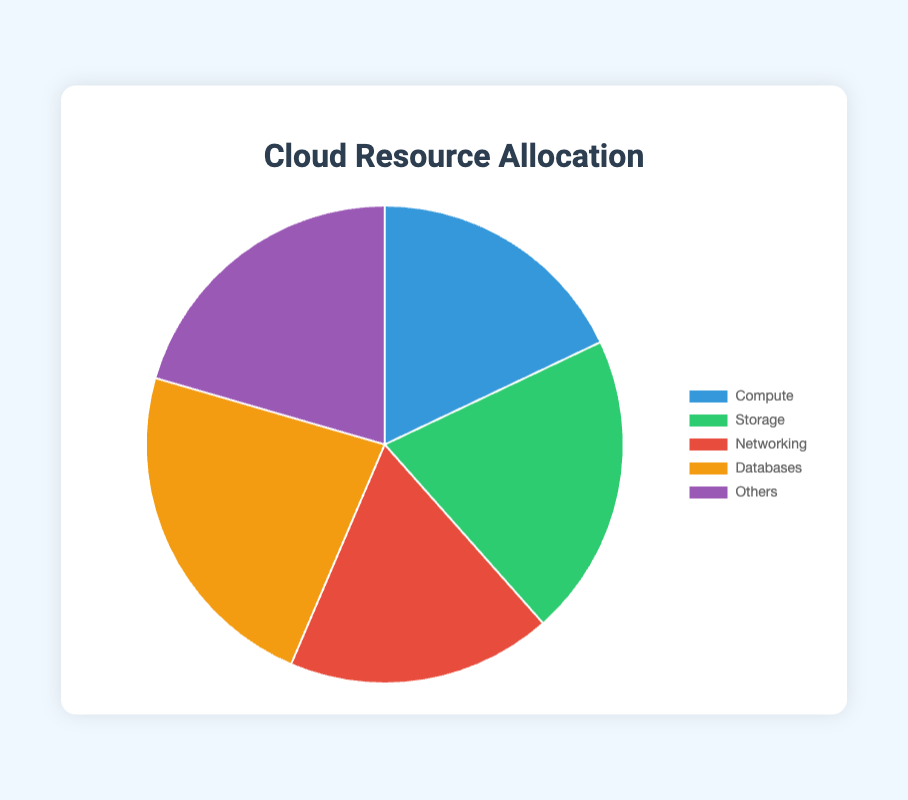Which service type has the highest resource allocation? The chart shows five segments representing different service types. The largest segment is for Databases.
Answer: Databases Which service type has the lowest resource allocation? The chart shows five segments representing different service types. The smallest segment is for Storage.
Answer: Storage Compare the resource allocation between Compute and Networking services. From the chart, Compute and Networking segments are the same size. Both have a resource allocation of 35%.
Answer: Equal What is the total resource allocation for Compute and Storage services combined? The chart shows Compute at 35% and Storage at 40%. Summing them gives 35 + 40 = 75.
Answer: 75% What is the percentage difference between the highest and lowest resource allocation? The highest allocation is 45% (Databases) and the lowest is 35% (Compute and Networking). The difference is 45 - 35 = 10.
Answer: 10% Which color represents the Networking service type? The chart uses specific colors for each service type. Networking is represented by the red segment.
Answer: Red What’s the average resource allocation across all service types? There are five service types with allocations of 35, 40, 35, 45, and 40. The sum is 35 + 40 + 35 + 45 + 40 = 195. The average is 195 / 5 = 39.
Answer: 39% Is the combined resource allocation for Compute and Databases more than 50%? The resource allocation for Compute is 35% and for Databases is 45%. Combined, they are 35 + 45 = 80%, which is greater than 50%.
Answer: Yes By how much does Storage's resource allocation exceed Compute's? Storage's resource allocation is 40%, and Compute's is 35%. The difference is 40 - 35 = 5.
Answer: 5% What proportion of the total resource allocation is taken up by services other than Compute? The total allocation not including Compute is Storage (40%), Networking (35%), Databases (45%), and Others (40%). Summing them gives 40 + 35 + 45 + 40 = 160%.
Answer: 160% 